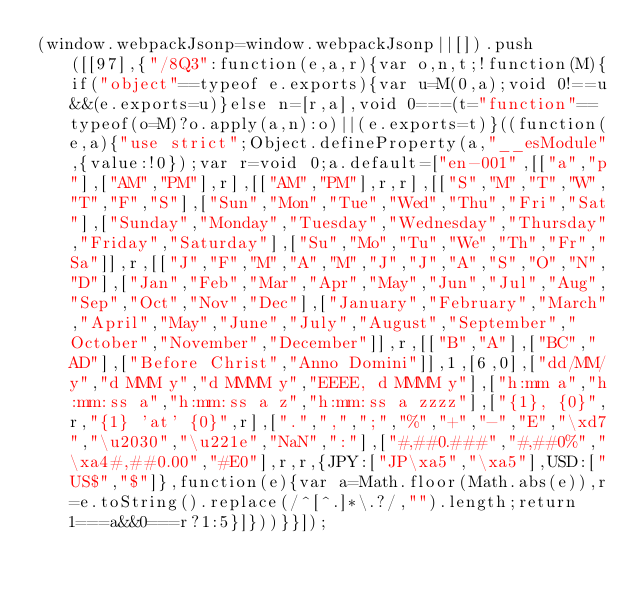<code> <loc_0><loc_0><loc_500><loc_500><_JavaScript_>(window.webpackJsonp=window.webpackJsonp||[]).push([[97],{"/8Q3":function(e,a,r){var o,n,t;!function(M){if("object"==typeof e.exports){var u=M(0,a);void 0!==u&&(e.exports=u)}else n=[r,a],void 0===(t="function"==typeof(o=M)?o.apply(a,n):o)||(e.exports=t)}((function(e,a){"use strict";Object.defineProperty(a,"__esModule",{value:!0});var r=void 0;a.default=["en-001",[["a","p"],["AM","PM"],r],[["AM","PM"],r,r],[["S","M","T","W","T","F","S"],["Sun","Mon","Tue","Wed","Thu","Fri","Sat"],["Sunday","Monday","Tuesday","Wednesday","Thursday","Friday","Saturday"],["Su","Mo","Tu","We","Th","Fr","Sa"]],r,[["J","F","M","A","M","J","J","A","S","O","N","D"],["Jan","Feb","Mar","Apr","May","Jun","Jul","Aug","Sep","Oct","Nov","Dec"],["January","February","March","April","May","June","July","August","September","October","November","December"]],r,[["B","A"],["BC","AD"],["Before Christ","Anno Domini"]],1,[6,0],["dd/MM/y","d MMM y","d MMMM y","EEEE, d MMMM y"],["h:mm a","h:mm:ss a","h:mm:ss a z","h:mm:ss a zzzz"],["{1}, {0}",r,"{1} 'at' {0}",r],[".",",",";","%","+","-","E","\xd7","\u2030","\u221e","NaN",":"],["#,##0.###","#,##0%","\xa4#,##0.00","#E0"],r,r,{JPY:["JP\xa5","\xa5"],USD:["US$","$"]},function(e){var a=Math.floor(Math.abs(e)),r=e.toString().replace(/^[^.]*\.?/,"").length;return 1===a&&0===r?1:5}]}))}}]);</code> 